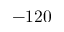Convert formula to latex. <formula><loc_0><loc_0><loc_500><loc_500>- 1 2 0</formula> 